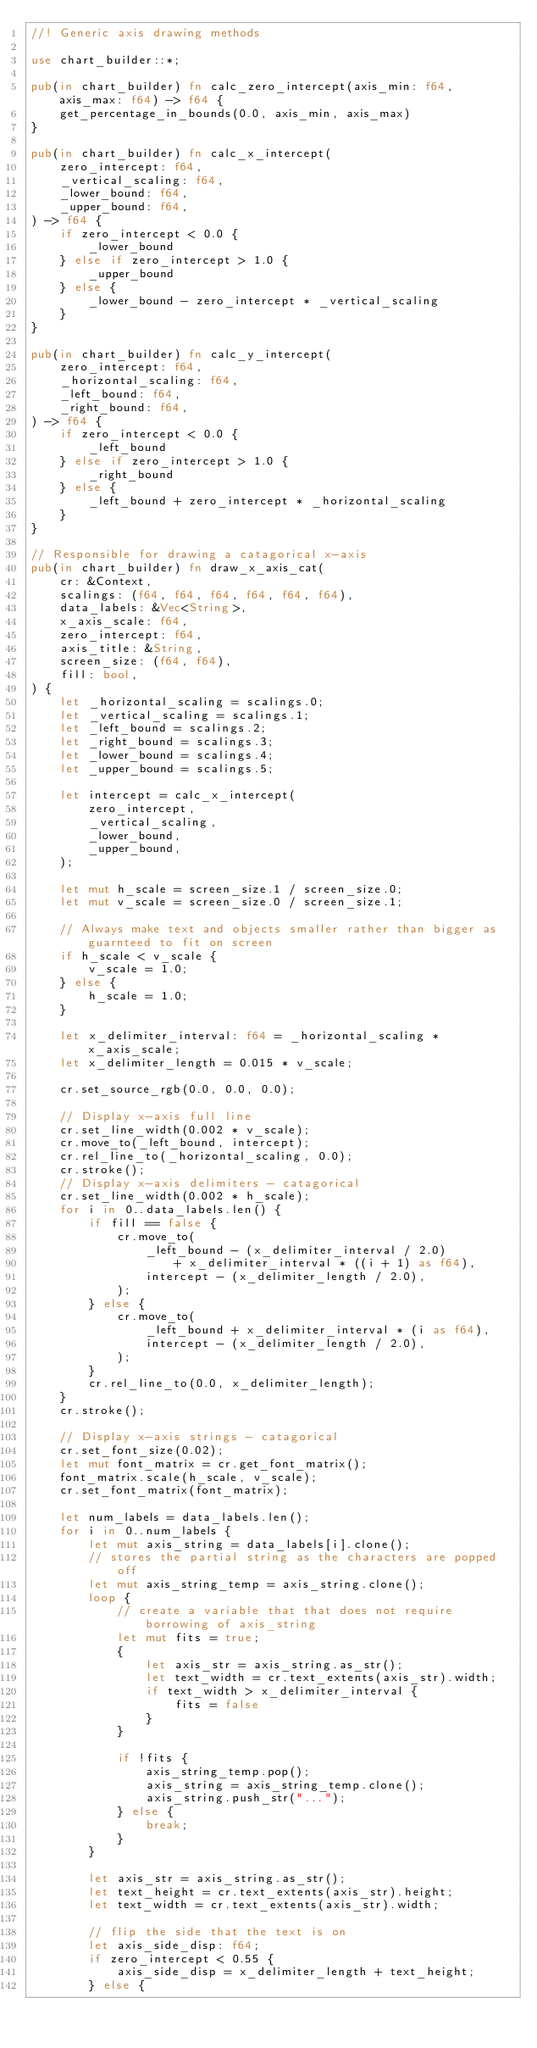Convert code to text. <code><loc_0><loc_0><loc_500><loc_500><_Rust_>//! Generic axis drawing methods

use chart_builder::*;

pub(in chart_builder) fn calc_zero_intercept(axis_min: f64, axis_max: f64) -> f64 {
    get_percentage_in_bounds(0.0, axis_min, axis_max)
}

pub(in chart_builder) fn calc_x_intercept(
    zero_intercept: f64,
    _vertical_scaling: f64,
    _lower_bound: f64,
    _upper_bound: f64,
) -> f64 {
    if zero_intercept < 0.0 {
        _lower_bound
    } else if zero_intercept > 1.0 {
        _upper_bound
    } else {
        _lower_bound - zero_intercept * _vertical_scaling
    }
}

pub(in chart_builder) fn calc_y_intercept(
    zero_intercept: f64,
    _horizontal_scaling: f64,
    _left_bound: f64,
    _right_bound: f64,
) -> f64 {
    if zero_intercept < 0.0 {
        _left_bound
    } else if zero_intercept > 1.0 {
        _right_bound
    } else {
        _left_bound + zero_intercept * _horizontal_scaling
    }
}

// Responsible for drawing a catagorical x-axis
pub(in chart_builder) fn draw_x_axis_cat(
    cr: &Context,
    scalings: (f64, f64, f64, f64, f64, f64),
    data_labels: &Vec<String>,
    x_axis_scale: f64,
    zero_intercept: f64,
    axis_title: &String,
    screen_size: (f64, f64),
    fill: bool,
) {
    let _horizontal_scaling = scalings.0;
    let _vertical_scaling = scalings.1;
    let _left_bound = scalings.2;
    let _right_bound = scalings.3;
    let _lower_bound = scalings.4;
    let _upper_bound = scalings.5;

    let intercept = calc_x_intercept(
        zero_intercept,
        _vertical_scaling,
        _lower_bound,
        _upper_bound,
    );

    let mut h_scale = screen_size.1 / screen_size.0;
    let mut v_scale = screen_size.0 / screen_size.1;

    // Always make text and objects smaller rather than bigger as guarnteed to fit on screen
    if h_scale < v_scale {
        v_scale = 1.0;
    } else {
        h_scale = 1.0;
    }

    let x_delimiter_interval: f64 = _horizontal_scaling * x_axis_scale;
    let x_delimiter_length = 0.015 * v_scale;

    cr.set_source_rgb(0.0, 0.0, 0.0);

    // Display x-axis full line
    cr.set_line_width(0.002 * v_scale);
    cr.move_to(_left_bound, intercept);
    cr.rel_line_to(_horizontal_scaling, 0.0);
    cr.stroke();
    // Display x-axis delimiters - catagorical
    cr.set_line_width(0.002 * h_scale);
    for i in 0..data_labels.len() {
        if fill == false {
            cr.move_to(
                _left_bound - (x_delimiter_interval / 2.0)
                    + x_delimiter_interval * ((i + 1) as f64),
                intercept - (x_delimiter_length / 2.0),
            );
        } else {
            cr.move_to(
                _left_bound + x_delimiter_interval * (i as f64),
                intercept - (x_delimiter_length / 2.0),
            );
        }
        cr.rel_line_to(0.0, x_delimiter_length);
    }
    cr.stroke();

    // Display x-axis strings - catagorical
    cr.set_font_size(0.02);
    let mut font_matrix = cr.get_font_matrix();
    font_matrix.scale(h_scale, v_scale);
    cr.set_font_matrix(font_matrix);

    let num_labels = data_labels.len();
    for i in 0..num_labels {
        let mut axis_string = data_labels[i].clone();
        // stores the partial string as the characters are popped off
        let mut axis_string_temp = axis_string.clone();
        loop {
            // create a variable that that does not require borrowing of axis_string
            let mut fits = true;
            {
                let axis_str = axis_string.as_str();
                let text_width = cr.text_extents(axis_str).width;
                if text_width > x_delimiter_interval {
                    fits = false
                }
            }

            if !fits {
                axis_string_temp.pop();
                axis_string = axis_string_temp.clone();
                axis_string.push_str("...");
            } else {
                break;
            }
        }

        let axis_str = axis_string.as_str();
        let text_height = cr.text_extents(axis_str).height;
        let text_width = cr.text_extents(axis_str).width;

        // flip the side that the text is on
        let axis_side_disp: f64;
        if zero_intercept < 0.55 {
            axis_side_disp = x_delimiter_length + text_height;
        } else {</code> 